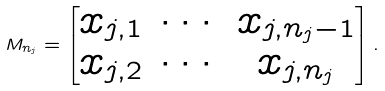Convert formula to latex. <formula><loc_0><loc_0><loc_500><loc_500>M _ { n _ { j } } = \begin{bmatrix} x _ { j , 1 } & \cdots & x _ { j , n _ { j } - 1 } \\ x _ { j , 2 } & \cdots & x _ { j , n _ { j } } \end{bmatrix} .</formula> 